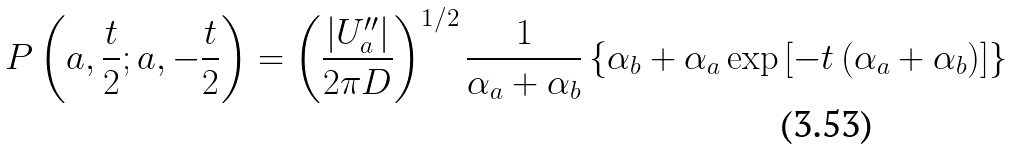<formula> <loc_0><loc_0><loc_500><loc_500>P \left ( a , \frac { t } { 2 } ; a , - \frac { t } { 2 } \right ) = \left ( \frac { \left | U _ { a } ^ { \prime \prime } \right | } { 2 \pi D } \right ) ^ { 1 / 2 } \frac { 1 } { \alpha _ { a } + \alpha _ { b } } \left \{ \alpha _ { b } + \alpha _ { a } \exp \left [ - t \left ( \alpha _ { a } + \alpha _ { b } \right ) \right ] \right \}</formula> 